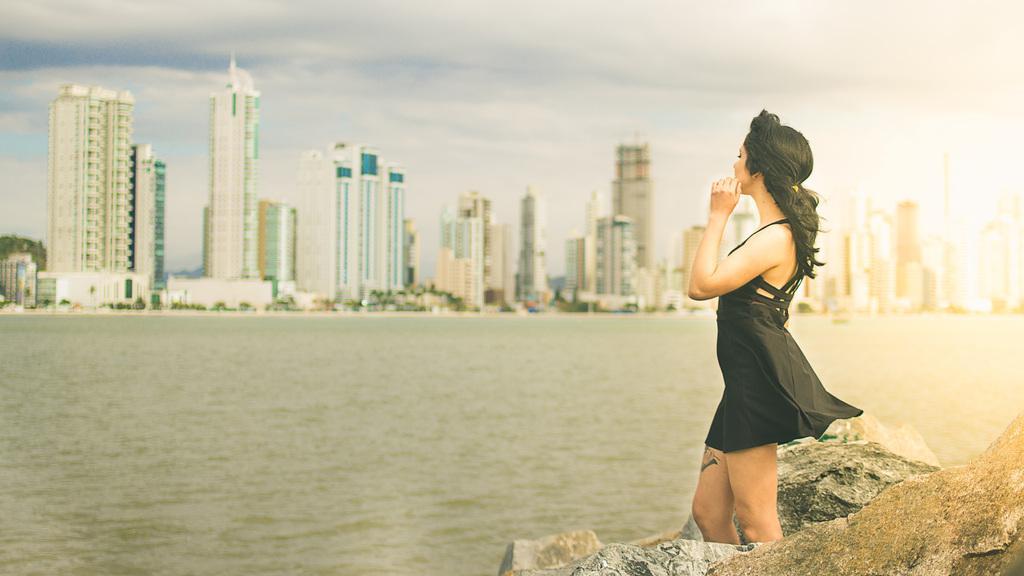In one or two sentences, can you explain what this image depicts? As we can see in the image there is water, a woman wearing black color dress and at the top there is sky. There are rocks and in the background there are buildings. 